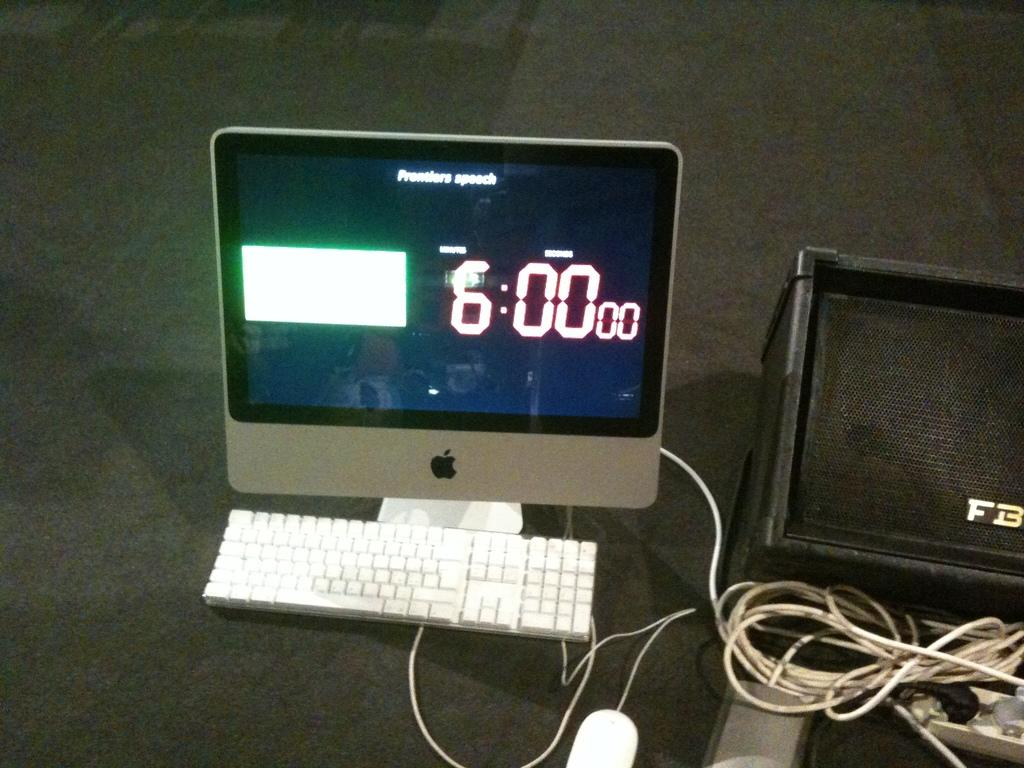<image>
Share a concise interpretation of the image provided. Monitor that is showing A white square box to the left and 6:00 00 on the right. 